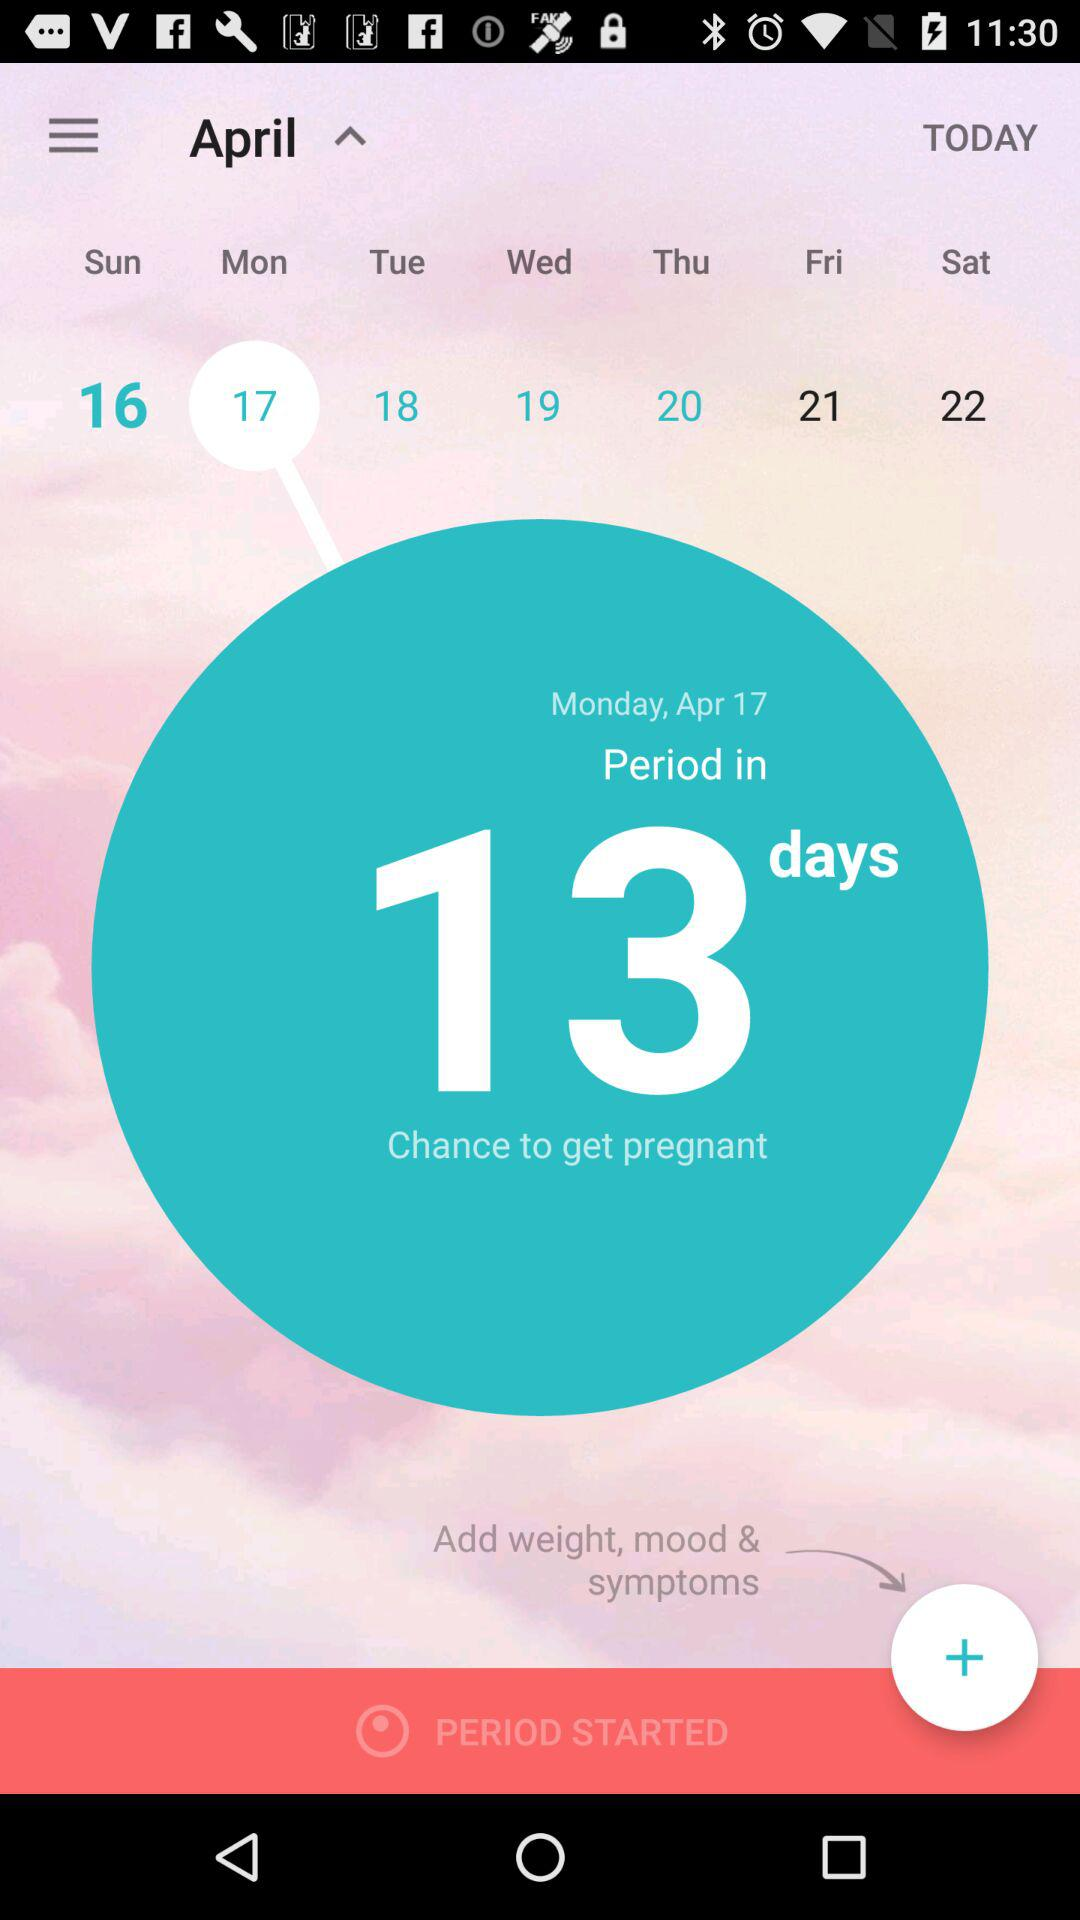What is the selected date? The selected date is Monday, April 17. 